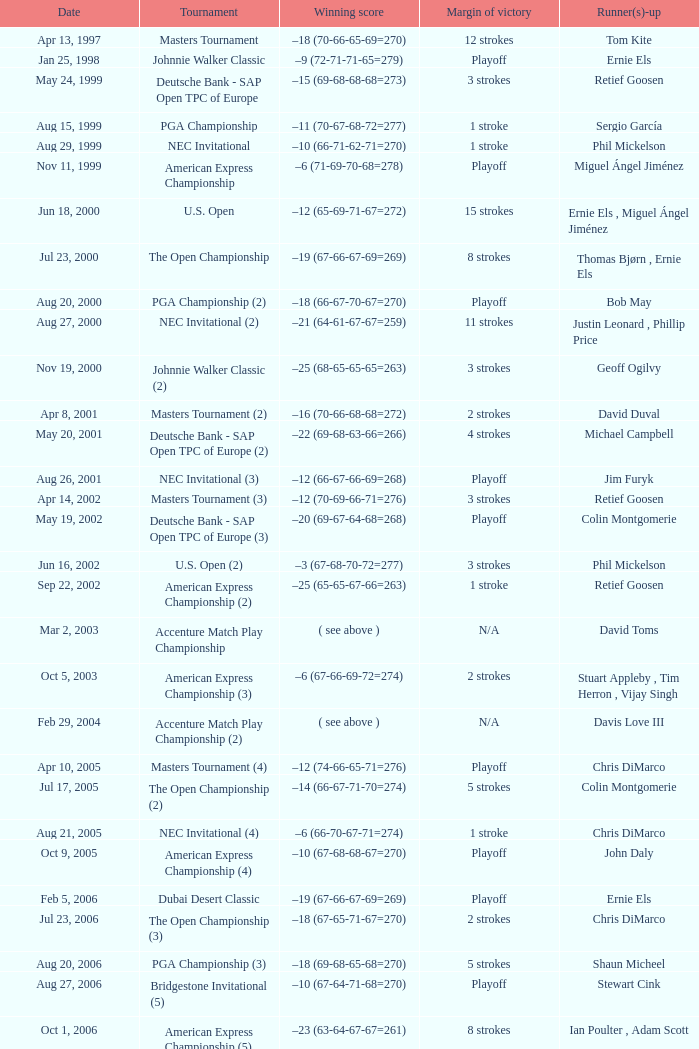Who holds the winning score of -10, with the breakdown being 66-71-62-71, and a sum of 270? Phil Mickelson. 